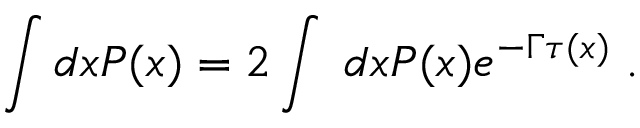<formula> <loc_0><loc_0><loc_500><loc_500>\int d x P ( x ) = 2 \int \, d x P ( x ) e ^ { - \Gamma \tau ( x ) } \, .</formula> 